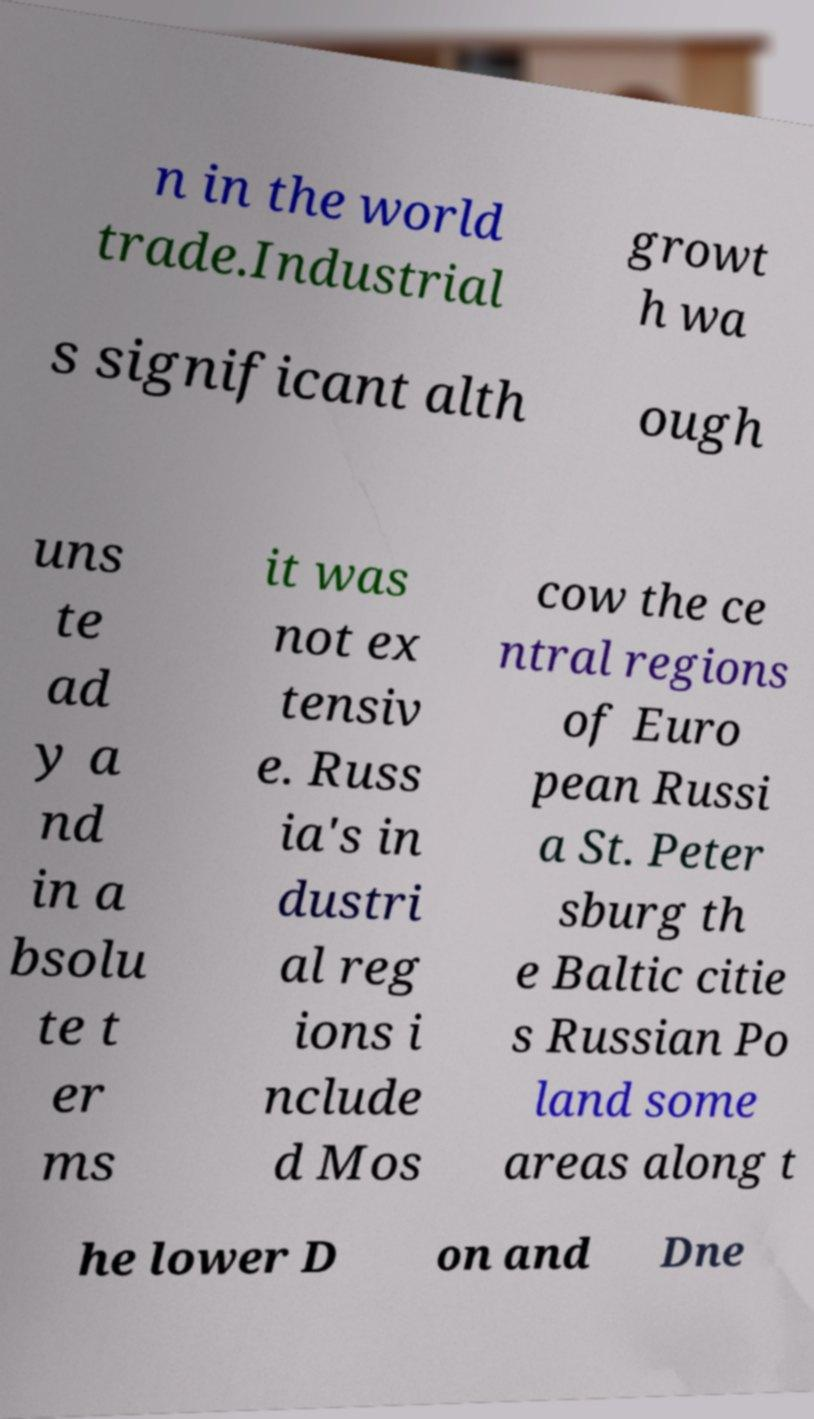What messages or text are displayed in this image? I need them in a readable, typed format. n in the world trade.Industrial growt h wa s significant alth ough uns te ad y a nd in a bsolu te t er ms it was not ex tensiv e. Russ ia's in dustri al reg ions i nclude d Mos cow the ce ntral regions of Euro pean Russi a St. Peter sburg th e Baltic citie s Russian Po land some areas along t he lower D on and Dne 